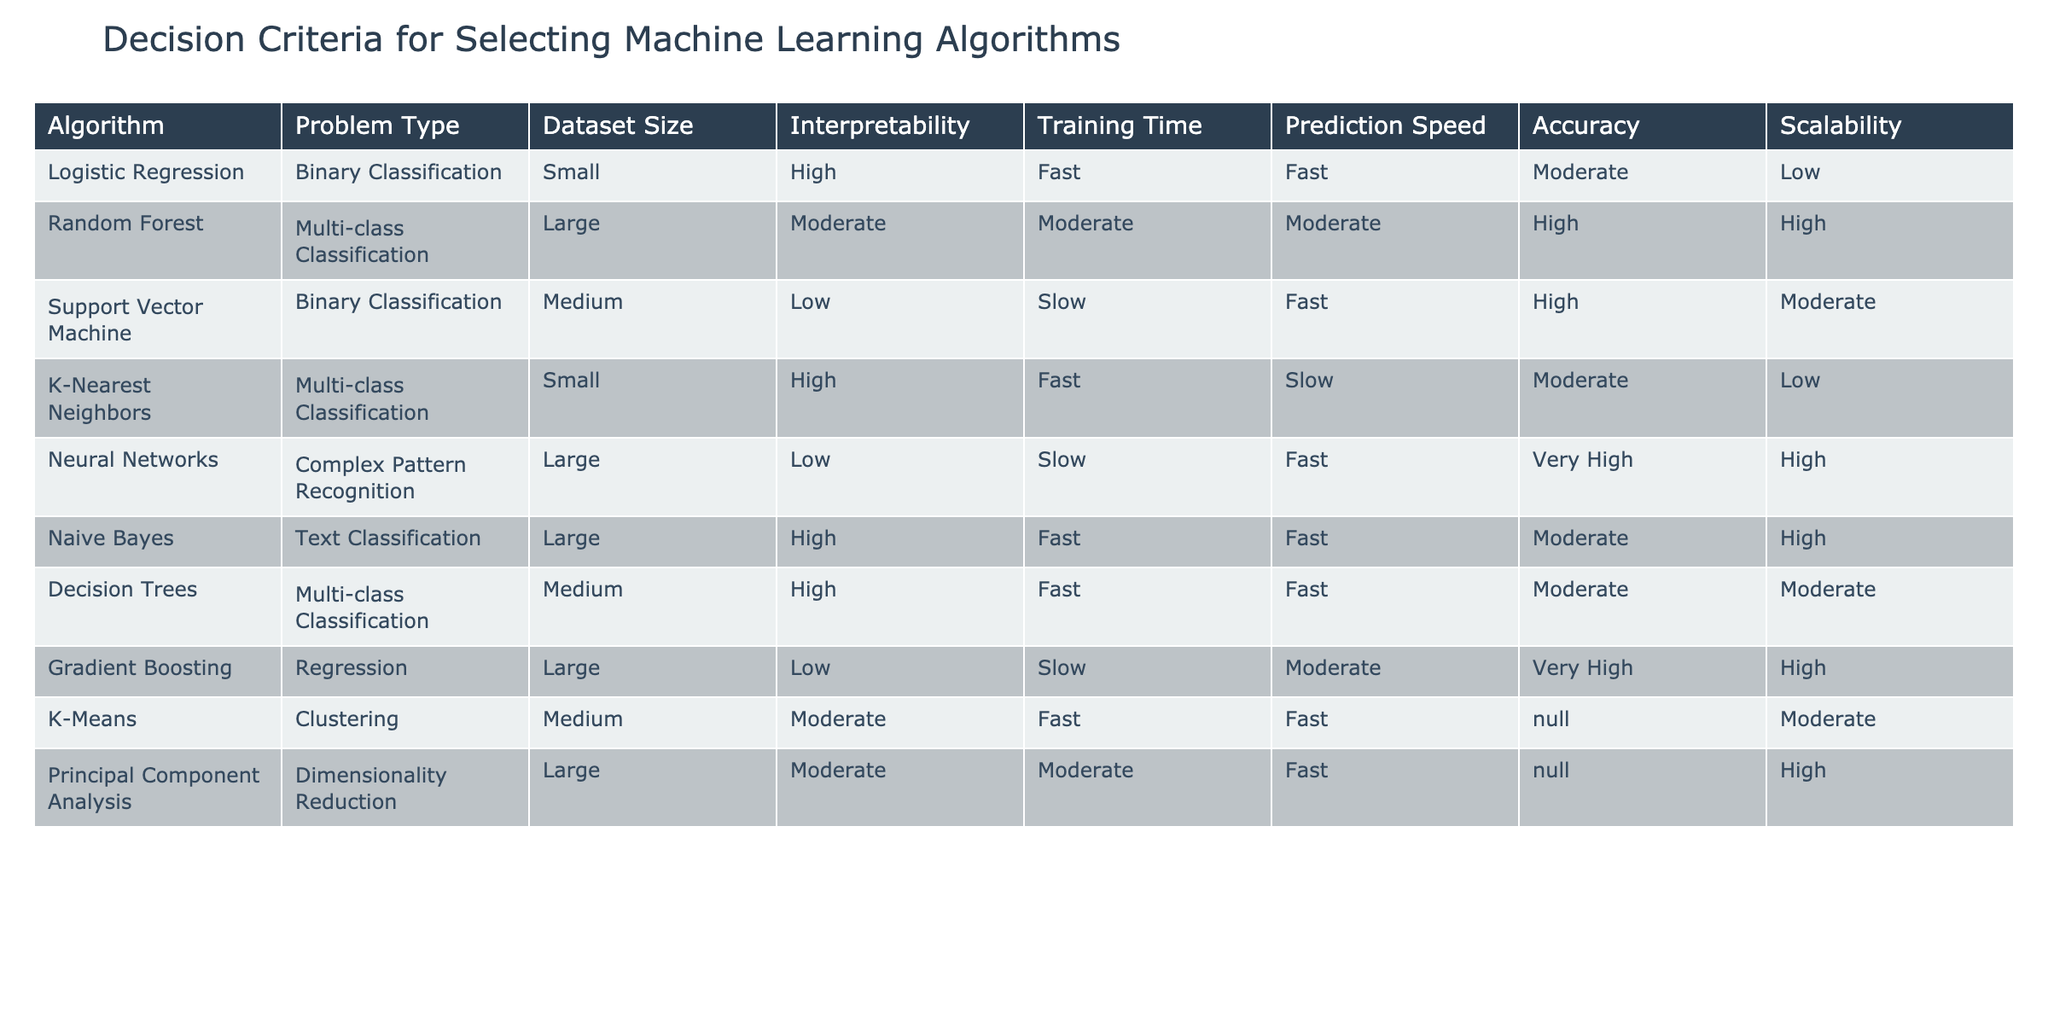What is the training time for Neural Networks? The table shows that the training time for Neural Networks is categorized as "Slow."
Answer: Slow Which algorithm has the highest accuracy according to the table? The table indicates that Neural Networks have the highest accuracy marked as "Very High."
Answer: Neural Networks Does Logistic Regression have high interpretability? Yes, the table states that Logistic Regression has "High" interpretability.
Answer: Yes Which algorithms are suitable for large datasets? The algorithms suitable for large datasets according to the table are Random Forest, Neural Networks, Naive Bayes, Gradient Boosting, and Principal Component Analysis.
Answer: Random Forest, Neural Networks, Naive Bayes, Gradient Boosting, Principal Component Analysis What is the average interpretability rating of all algorithms listed? To find the average interpretability rating, we categorize it numerically as follows: High=3, Moderate=2, Low=1. The sum of interpretability ratings is (3 + 2 + 1 + 3 + 2 + 3 + 2 + 1 + 2 + 2) = 21. There are 10 algorithms, so the average is 21/10 = 2.1, which corresponds to a rating between Moderate and High.
Answer: Moderate Are Decision Trees faster in prediction speed compared to K-Nearest Neighbors? Yes, the table shows that Decision Trees have "Fast" prediction speed while K-Nearest Neighbors is categorized as "Slow."
Answer: Yes What proportion of the algorithms listed has high scalability? The algorithms that have high scalability according to the table are Random Forest, Neural Networks, Naive Bayes, Gradient Boosting, and Principal Component Analysis, totaling to 5. Since there are 10 algorithms in total, the proportion is 5/10 = 0.5.
Answer: 0.5 Which algorithms are suitable for multi-class classification and have high interpretability? Analyzing the table, Decision Trees and Random Forest are suitable for multi-class classification and have at least Moderate interpretability. Decision Trees has "High" interpretability while Random Forest has "Moderate." Thus, the answer is Decision Trees.
Answer: Decision Trees What is the relationship between dataset size and accuracy for the algorithms listed? The dataset size has no direct relationship with accuracy across all algorithms, as some algorithms with large datasets like Random Forest and Neural Networks have high accuracy, while others with large datasets like Naive Bayes have moderate accuracy. This indicates that accuracy can depend on the type of algorithm used rather than just dataset size.
Answer: No direct relationship 